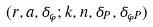Convert formula to latex. <formula><loc_0><loc_0><loc_500><loc_500>( r , a , \delta _ { \varphi } ; k , n , \delta _ { P } , \delta _ { \varphi P } )</formula> 